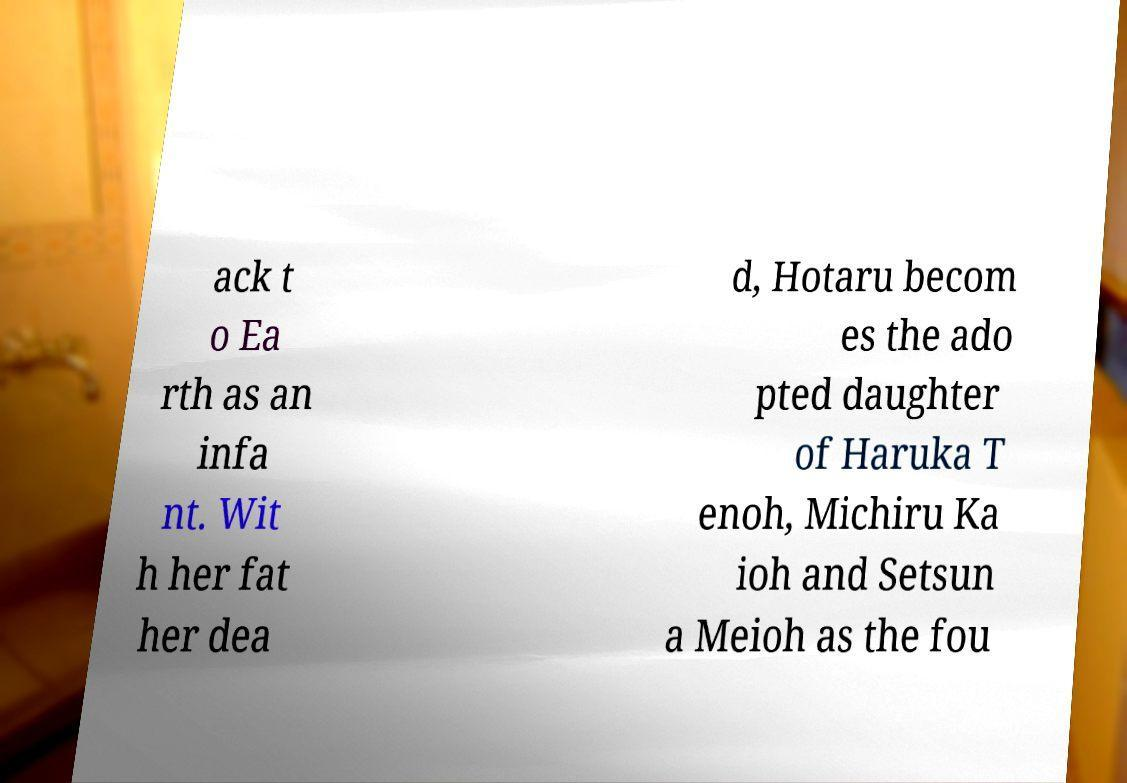Please identify and transcribe the text found in this image. ack t o Ea rth as an infa nt. Wit h her fat her dea d, Hotaru becom es the ado pted daughter of Haruka T enoh, Michiru Ka ioh and Setsun a Meioh as the fou 